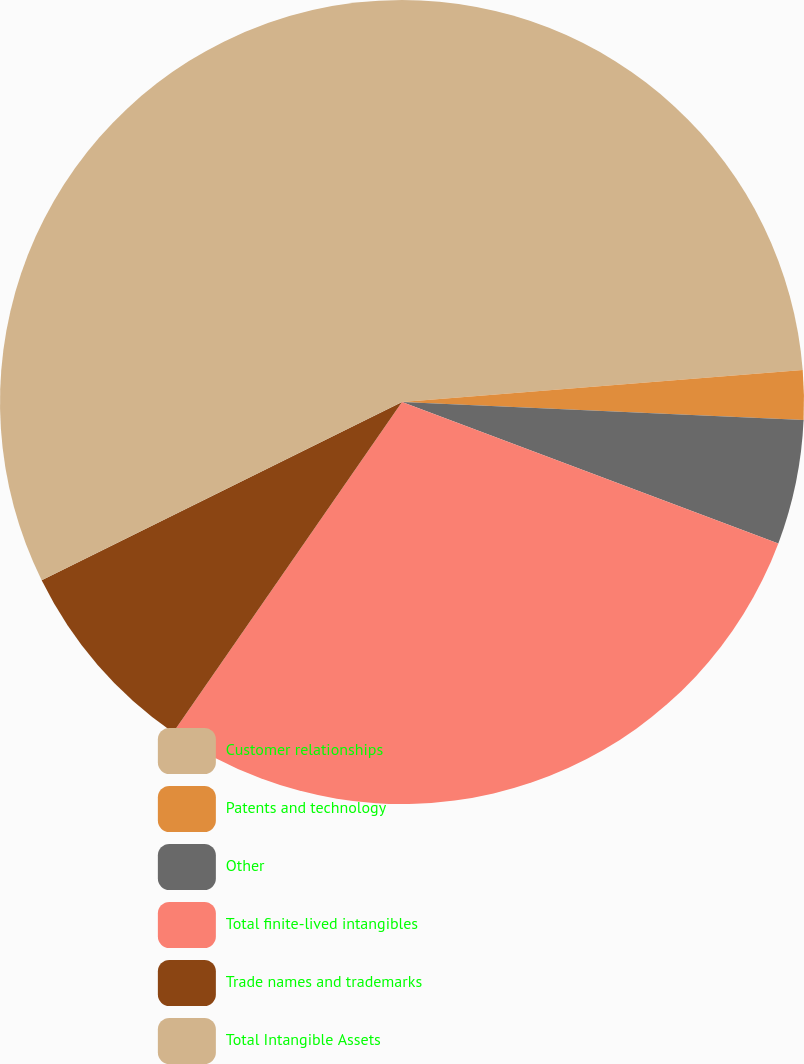Convert chart. <chart><loc_0><loc_0><loc_500><loc_500><pie_chart><fcel>Customer relationships<fcel>Patents and technology<fcel>Other<fcel>Total finite-lived intangibles<fcel>Trade names and trademarks<fcel>Total Intangible Assets<nl><fcel>23.73%<fcel>1.98%<fcel>5.01%<fcel>28.92%<fcel>8.05%<fcel>32.31%<nl></chart> 